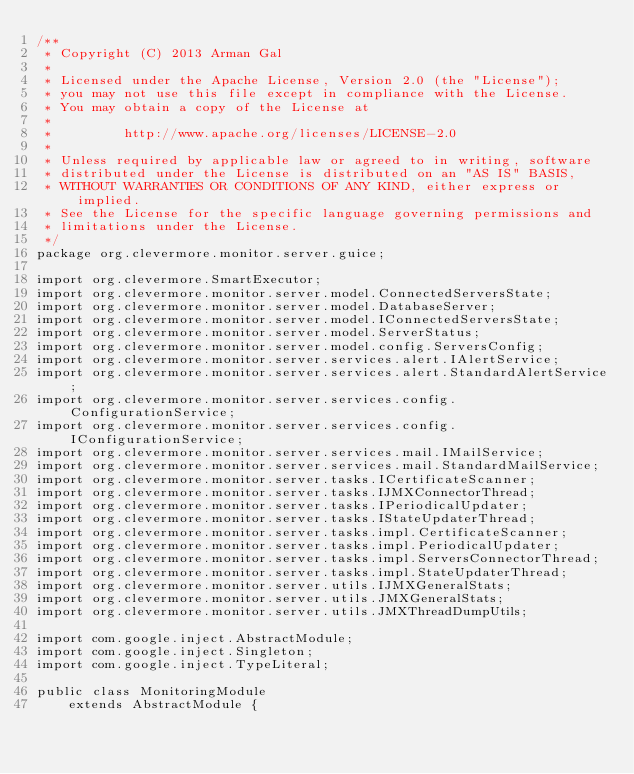Convert code to text. <code><loc_0><loc_0><loc_500><loc_500><_Java_>/**
 * Copyright (C) 2013 Arman Gal
 *
 * Licensed under the Apache License, Version 2.0 (the "License");
 * you may not use this file except in compliance with the License.
 * You may obtain a copy of the License at
 *
 *         http://www.apache.org/licenses/LICENSE-2.0
 *
 * Unless required by applicable law or agreed to in writing, software
 * distributed under the License is distributed on an "AS IS" BASIS,
 * WITHOUT WARRANTIES OR CONDITIONS OF ANY KIND, either express or implied.
 * See the License for the specific language governing permissions and
 * limitations under the License.
 */
package org.clevermore.monitor.server.guice;

import org.clevermore.SmartExecutor;
import org.clevermore.monitor.server.model.ConnectedServersState;
import org.clevermore.monitor.server.model.DatabaseServer;
import org.clevermore.monitor.server.model.IConnectedServersState;
import org.clevermore.monitor.server.model.ServerStatus;
import org.clevermore.monitor.server.model.config.ServersConfig;
import org.clevermore.monitor.server.services.alert.IAlertService;
import org.clevermore.monitor.server.services.alert.StandardAlertService;
import org.clevermore.monitor.server.services.config.ConfigurationService;
import org.clevermore.monitor.server.services.config.IConfigurationService;
import org.clevermore.monitor.server.services.mail.IMailService;
import org.clevermore.monitor.server.services.mail.StandardMailService;
import org.clevermore.monitor.server.tasks.ICertificateScanner;
import org.clevermore.monitor.server.tasks.IJMXConnectorThread;
import org.clevermore.monitor.server.tasks.IPeriodicalUpdater;
import org.clevermore.monitor.server.tasks.IStateUpdaterThread;
import org.clevermore.monitor.server.tasks.impl.CertificateScanner;
import org.clevermore.monitor.server.tasks.impl.PeriodicalUpdater;
import org.clevermore.monitor.server.tasks.impl.ServersConnectorThread;
import org.clevermore.monitor.server.tasks.impl.StateUpdaterThread;
import org.clevermore.monitor.server.utils.IJMXGeneralStats;
import org.clevermore.monitor.server.utils.JMXGeneralStats;
import org.clevermore.monitor.server.utils.JMXThreadDumpUtils;

import com.google.inject.AbstractModule;
import com.google.inject.Singleton;
import com.google.inject.TypeLiteral;

public class MonitoringModule
    extends AbstractModule {
</code> 